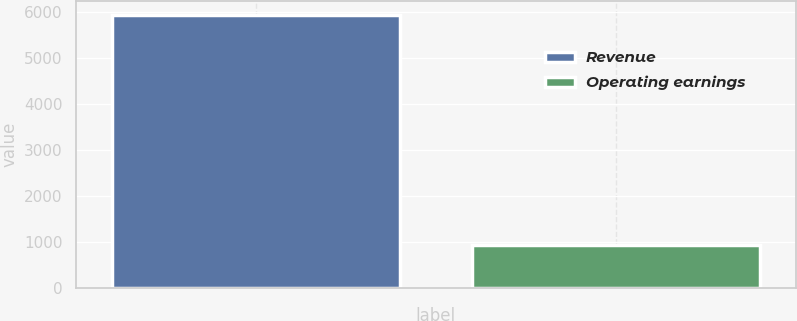Convert chart. <chart><loc_0><loc_0><loc_500><loc_500><bar_chart><fcel>Revenue<fcel>Operating earnings<nl><fcel>5949<fcel>937<nl></chart> 